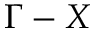Convert formula to latex. <formula><loc_0><loc_0><loc_500><loc_500>\Gamma - X</formula> 